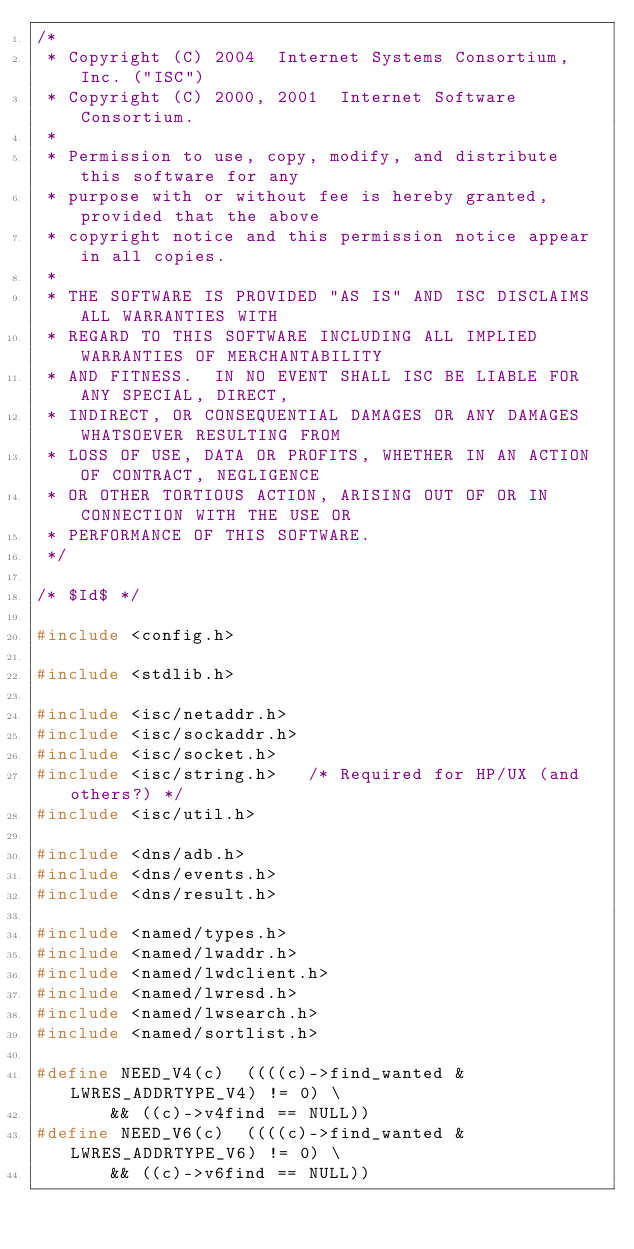Convert code to text. <code><loc_0><loc_0><loc_500><loc_500><_C_>/*
 * Copyright (C) 2004  Internet Systems Consortium, Inc. ("ISC")
 * Copyright (C) 2000, 2001  Internet Software Consortium.
 *
 * Permission to use, copy, modify, and distribute this software for any
 * purpose with or without fee is hereby granted, provided that the above
 * copyright notice and this permission notice appear in all copies.
 *
 * THE SOFTWARE IS PROVIDED "AS IS" AND ISC DISCLAIMS ALL WARRANTIES WITH
 * REGARD TO THIS SOFTWARE INCLUDING ALL IMPLIED WARRANTIES OF MERCHANTABILITY
 * AND FITNESS.  IN NO EVENT SHALL ISC BE LIABLE FOR ANY SPECIAL, DIRECT,
 * INDIRECT, OR CONSEQUENTIAL DAMAGES OR ANY DAMAGES WHATSOEVER RESULTING FROM
 * LOSS OF USE, DATA OR PROFITS, WHETHER IN AN ACTION OF CONTRACT, NEGLIGENCE
 * OR OTHER TORTIOUS ACTION, ARISING OUT OF OR IN CONNECTION WITH THE USE OR
 * PERFORMANCE OF THIS SOFTWARE.
 */

/* $Id$ */

#include <config.h>

#include <stdlib.h>

#include <isc/netaddr.h>
#include <isc/sockaddr.h>
#include <isc/socket.h>
#include <isc/string.h>		/* Required for HP/UX (and others?) */
#include <isc/util.h>

#include <dns/adb.h>
#include <dns/events.h>
#include <dns/result.h>

#include <named/types.h>
#include <named/lwaddr.h>
#include <named/lwdclient.h>
#include <named/lwresd.h>
#include <named/lwsearch.h>
#include <named/sortlist.h>

#define NEED_V4(c)	((((c)->find_wanted & LWRES_ADDRTYPE_V4) != 0) \
			 && ((c)->v4find == NULL))
#define NEED_V6(c)	((((c)->find_wanted & LWRES_ADDRTYPE_V6) != 0) \
			 && ((c)->v6find == NULL))
</code> 